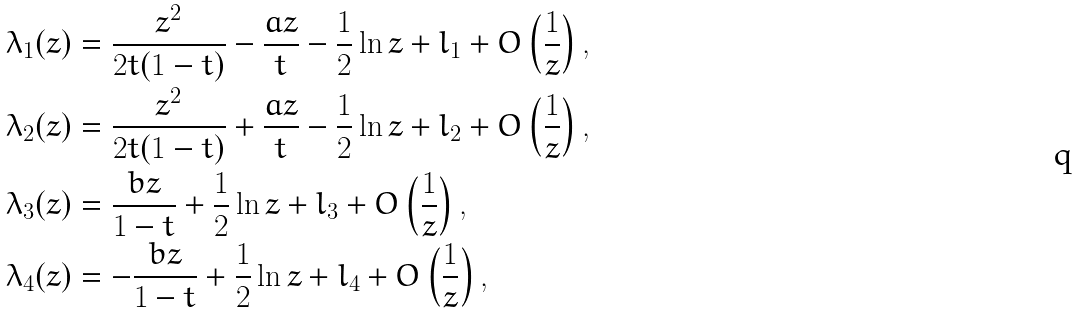<formula> <loc_0><loc_0><loc_500><loc_500>\lambda _ { 1 } ( z ) & = \frac { z ^ { 2 } } { 2 t ( 1 - t ) } - \frac { a z } { t } - \frac { 1 } { 2 } \ln z + l _ { 1 } + O \left ( \frac { 1 } { z } \right ) , \\ \lambda _ { 2 } ( z ) & = \frac { z ^ { 2 } } { 2 t ( 1 - t ) } + \frac { a z } { t } - \frac { 1 } { 2 } \ln z + l _ { 2 } + O \left ( \frac { 1 } { z } \right ) , \\ \lambda _ { 3 } ( z ) & = \frac { b z } { 1 - t } + \frac { 1 } { 2 } \ln z + l _ { 3 } + O \left ( \frac { 1 } { z } \right ) , \\ \lambda _ { 4 } ( z ) & = - \frac { b z } { 1 - t } + \frac { 1 } { 2 } \ln z + l _ { 4 } + O \left ( \frac { 1 } { z } \right ) ,</formula> 